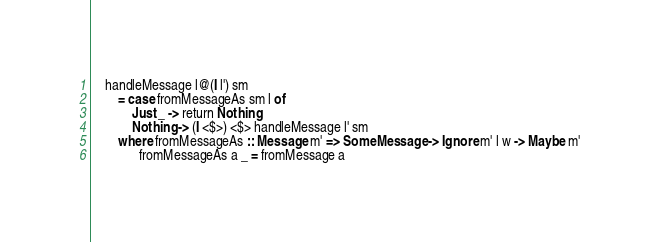Convert code to text. <code><loc_0><loc_0><loc_500><loc_500><_Haskell_>    handleMessage l@(I l') sm
        = case fromMessageAs sm l of
            Just _ -> return Nothing
            Nothing -> (I <$>) <$> handleMessage l' sm
        where fromMessageAs :: Message m' => SomeMessage -> Ignore m' l w -> Maybe m'
              fromMessageAs a _ = fromMessage a</code> 